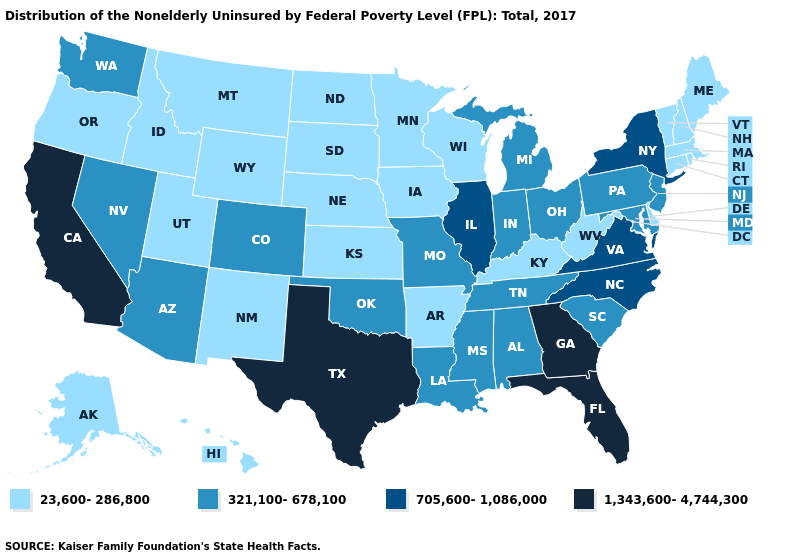Name the states that have a value in the range 1,343,600-4,744,300?
Keep it brief. California, Florida, Georgia, Texas. Does California have the lowest value in the USA?
Be succinct. No. Among the states that border California , which have the highest value?
Be succinct. Arizona, Nevada. Does Tennessee have the lowest value in the USA?
Write a very short answer. No. What is the highest value in the USA?
Give a very brief answer. 1,343,600-4,744,300. What is the lowest value in the MidWest?
Quick response, please. 23,600-286,800. Name the states that have a value in the range 705,600-1,086,000?
Answer briefly. Illinois, New York, North Carolina, Virginia. Name the states that have a value in the range 321,100-678,100?
Quick response, please. Alabama, Arizona, Colorado, Indiana, Louisiana, Maryland, Michigan, Mississippi, Missouri, Nevada, New Jersey, Ohio, Oklahoma, Pennsylvania, South Carolina, Tennessee, Washington. What is the value of Nevada?
Quick response, please. 321,100-678,100. How many symbols are there in the legend?
Give a very brief answer. 4. Does California have the highest value in the West?
Quick response, please. Yes. What is the lowest value in states that border Nebraska?
Concise answer only. 23,600-286,800. What is the lowest value in the South?
Quick response, please. 23,600-286,800. Among the states that border Montana , which have the lowest value?
Short answer required. Idaho, North Dakota, South Dakota, Wyoming. 